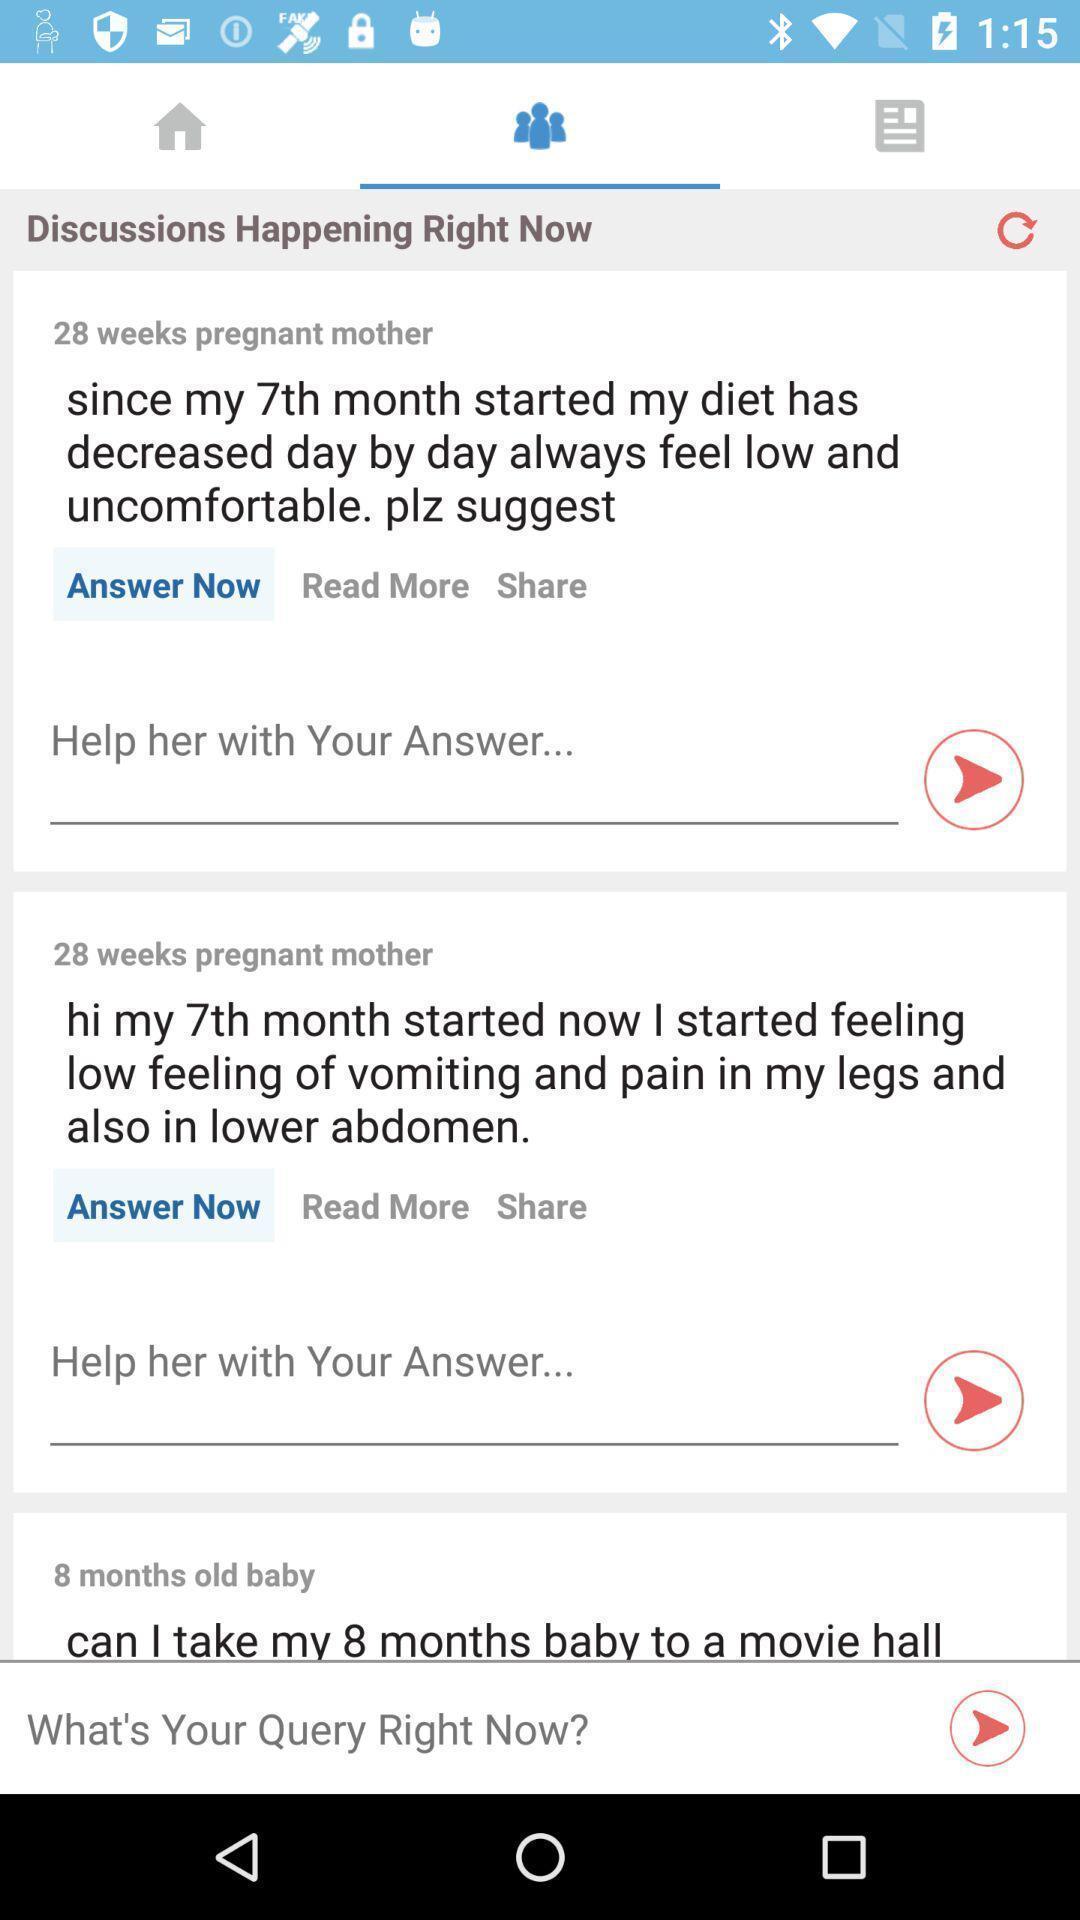Tell me what you see in this picture. Screen showing posted query 's. 